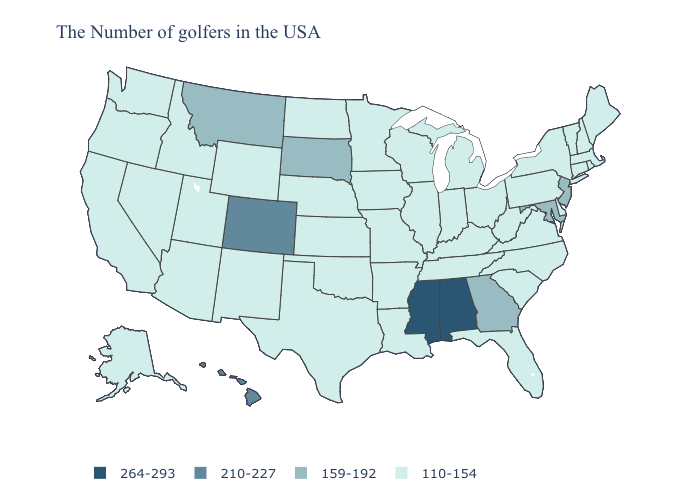Does Montana have the highest value in the USA?
Concise answer only. No. Name the states that have a value in the range 210-227?
Short answer required. Colorado, Hawaii. Name the states that have a value in the range 110-154?
Quick response, please. Maine, Massachusetts, Rhode Island, New Hampshire, Vermont, Connecticut, New York, Delaware, Pennsylvania, Virginia, North Carolina, South Carolina, West Virginia, Ohio, Florida, Michigan, Kentucky, Indiana, Tennessee, Wisconsin, Illinois, Louisiana, Missouri, Arkansas, Minnesota, Iowa, Kansas, Nebraska, Oklahoma, Texas, North Dakota, Wyoming, New Mexico, Utah, Arizona, Idaho, Nevada, California, Washington, Oregon, Alaska. Which states have the highest value in the USA?
Keep it brief. Alabama, Mississippi. Among the states that border Massachusetts , which have the lowest value?
Give a very brief answer. Rhode Island, New Hampshire, Vermont, Connecticut, New York. Which states hav the highest value in the West?
Concise answer only. Colorado, Hawaii. Which states hav the highest value in the MidWest?
Quick response, please. South Dakota. Does North Dakota have a lower value than Alabama?
Be succinct. Yes. What is the value of Minnesota?
Answer briefly. 110-154. Name the states that have a value in the range 264-293?
Give a very brief answer. Alabama, Mississippi. Name the states that have a value in the range 264-293?
Be succinct. Alabama, Mississippi. What is the value of Pennsylvania?
Concise answer only. 110-154. Which states have the lowest value in the USA?
Concise answer only. Maine, Massachusetts, Rhode Island, New Hampshire, Vermont, Connecticut, New York, Delaware, Pennsylvania, Virginia, North Carolina, South Carolina, West Virginia, Ohio, Florida, Michigan, Kentucky, Indiana, Tennessee, Wisconsin, Illinois, Louisiana, Missouri, Arkansas, Minnesota, Iowa, Kansas, Nebraska, Oklahoma, Texas, North Dakota, Wyoming, New Mexico, Utah, Arizona, Idaho, Nevada, California, Washington, Oregon, Alaska. What is the value of New York?
Answer briefly. 110-154. Does the map have missing data?
Concise answer only. No. 